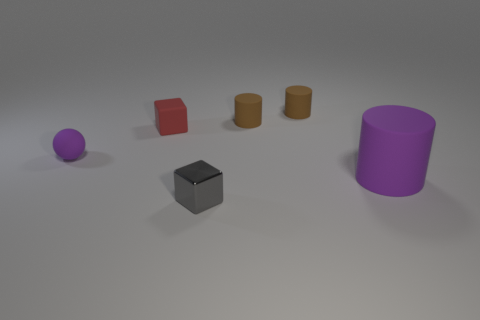How does the lighting in this image affect the appearance of the objects? The lighting in this image creates soft shadows that enhance the objects' dimensionality, making their shapes more discernible. It is likely there is a single light source given the direction of the shadows, which appears to be relatively diffused, reducing harsh contrasts and allowing the colors and textures to present naturally without being overly dramatic. 